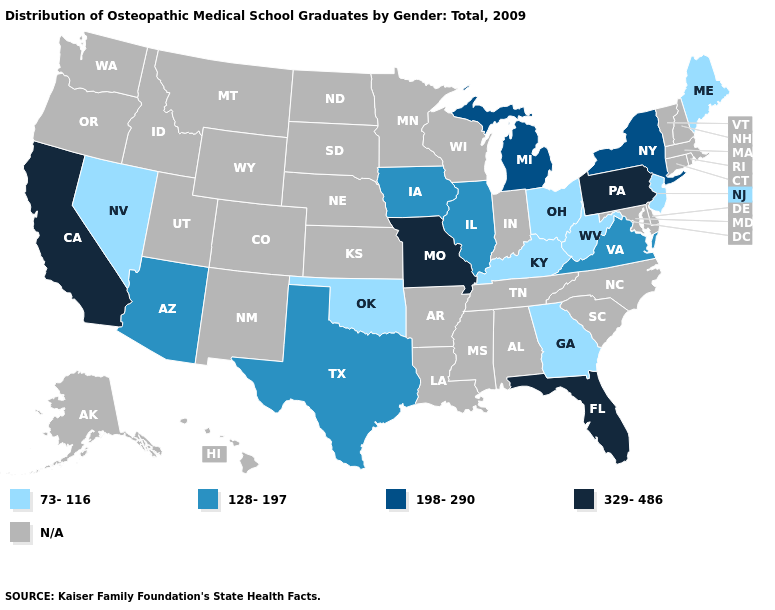What is the highest value in the West ?
Write a very short answer. 329-486. What is the value of Vermont?
Give a very brief answer. N/A. What is the value of Idaho?
Short answer required. N/A. Which states hav the highest value in the West?
Write a very short answer. California. Name the states that have a value in the range 329-486?
Short answer required. California, Florida, Missouri, Pennsylvania. What is the value of New York?
Quick response, please. 198-290. What is the highest value in the West ?
Write a very short answer. 329-486. Does Ohio have the lowest value in the USA?
Short answer required. Yes. Which states have the lowest value in the Northeast?
Be succinct. Maine, New Jersey. Does the map have missing data?
Write a very short answer. Yes. Name the states that have a value in the range 198-290?
Give a very brief answer. Michigan, New York. What is the value of Washington?
Be succinct. N/A. 